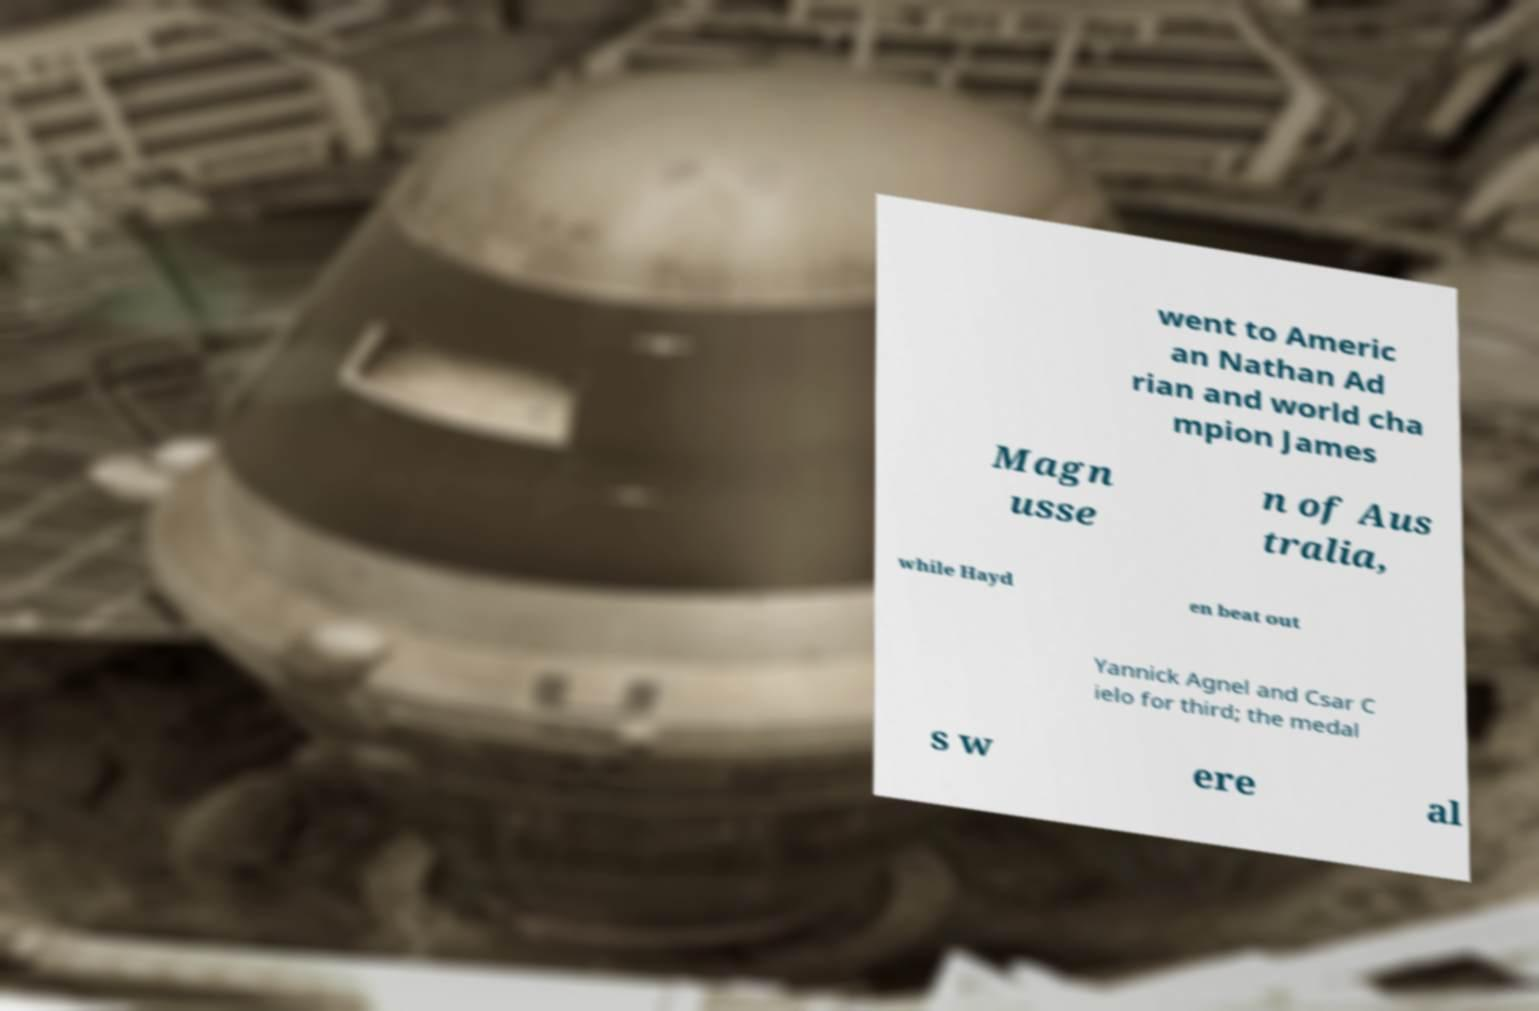Please read and relay the text visible in this image. What does it say? went to Americ an Nathan Ad rian and world cha mpion James Magn usse n of Aus tralia, while Hayd en beat out Yannick Agnel and Csar C ielo for third; the medal s w ere al 